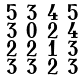Convert formula to latex. <formula><loc_0><loc_0><loc_500><loc_500>\begin{smallmatrix} 5 & 3 & 4 & 5 \\ 3 & 0 & 2 & 4 \\ 2 & 2 & 1 & 3 \\ 3 & 3 & 2 & 3 \end{smallmatrix}</formula> 